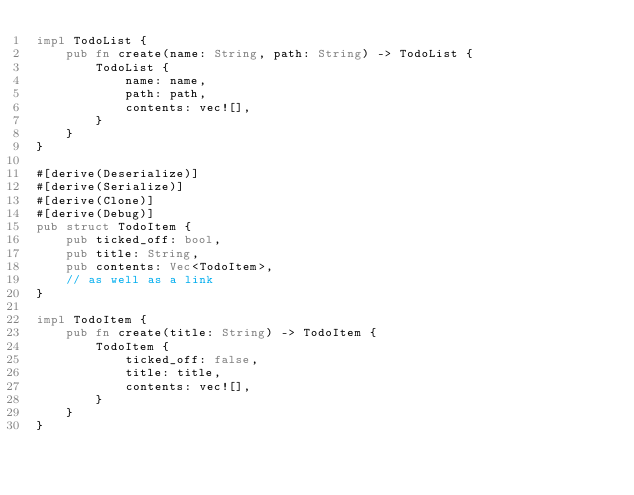Convert code to text. <code><loc_0><loc_0><loc_500><loc_500><_Rust_>impl TodoList {
    pub fn create(name: String, path: String) -> TodoList {
        TodoList {
            name: name,
            path: path,
            contents: vec![],
        }
    }
}

#[derive(Deserialize)]
#[derive(Serialize)]
#[derive(Clone)]
#[derive(Debug)]
pub struct TodoItem {
    pub ticked_off: bool,
    pub title: String,
    pub contents: Vec<TodoItem>,
    // as well as a link
}

impl TodoItem {
    pub fn create(title: String) -> TodoItem {
        TodoItem {
            ticked_off: false,
            title: title,
            contents: vec![],
        }
    }
}
</code> 